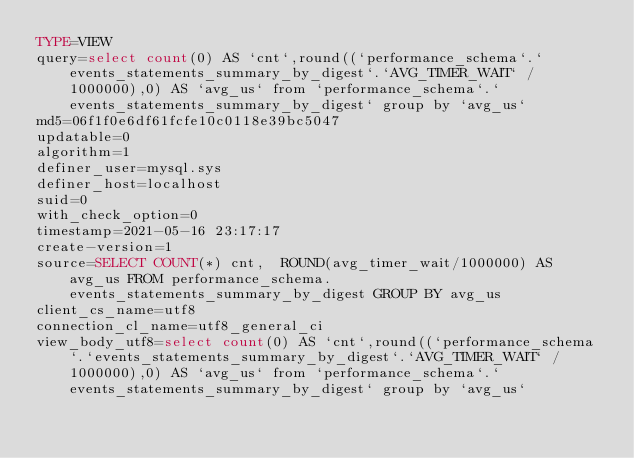<code> <loc_0><loc_0><loc_500><loc_500><_VisualBasic_>TYPE=VIEW
query=select count(0) AS `cnt`,round((`performance_schema`.`events_statements_summary_by_digest`.`AVG_TIMER_WAIT` / 1000000),0) AS `avg_us` from `performance_schema`.`events_statements_summary_by_digest` group by `avg_us`
md5=06f1f0e6df61fcfe10c0118e39bc5047
updatable=0
algorithm=1
definer_user=mysql.sys
definer_host=localhost
suid=0
with_check_option=0
timestamp=2021-05-16 23:17:17
create-version=1
source=SELECT COUNT(*) cnt,  ROUND(avg_timer_wait/1000000) AS avg_us FROM performance_schema.events_statements_summary_by_digest GROUP BY avg_us
client_cs_name=utf8
connection_cl_name=utf8_general_ci
view_body_utf8=select count(0) AS `cnt`,round((`performance_schema`.`events_statements_summary_by_digest`.`AVG_TIMER_WAIT` / 1000000),0) AS `avg_us` from `performance_schema`.`events_statements_summary_by_digest` group by `avg_us`
</code> 